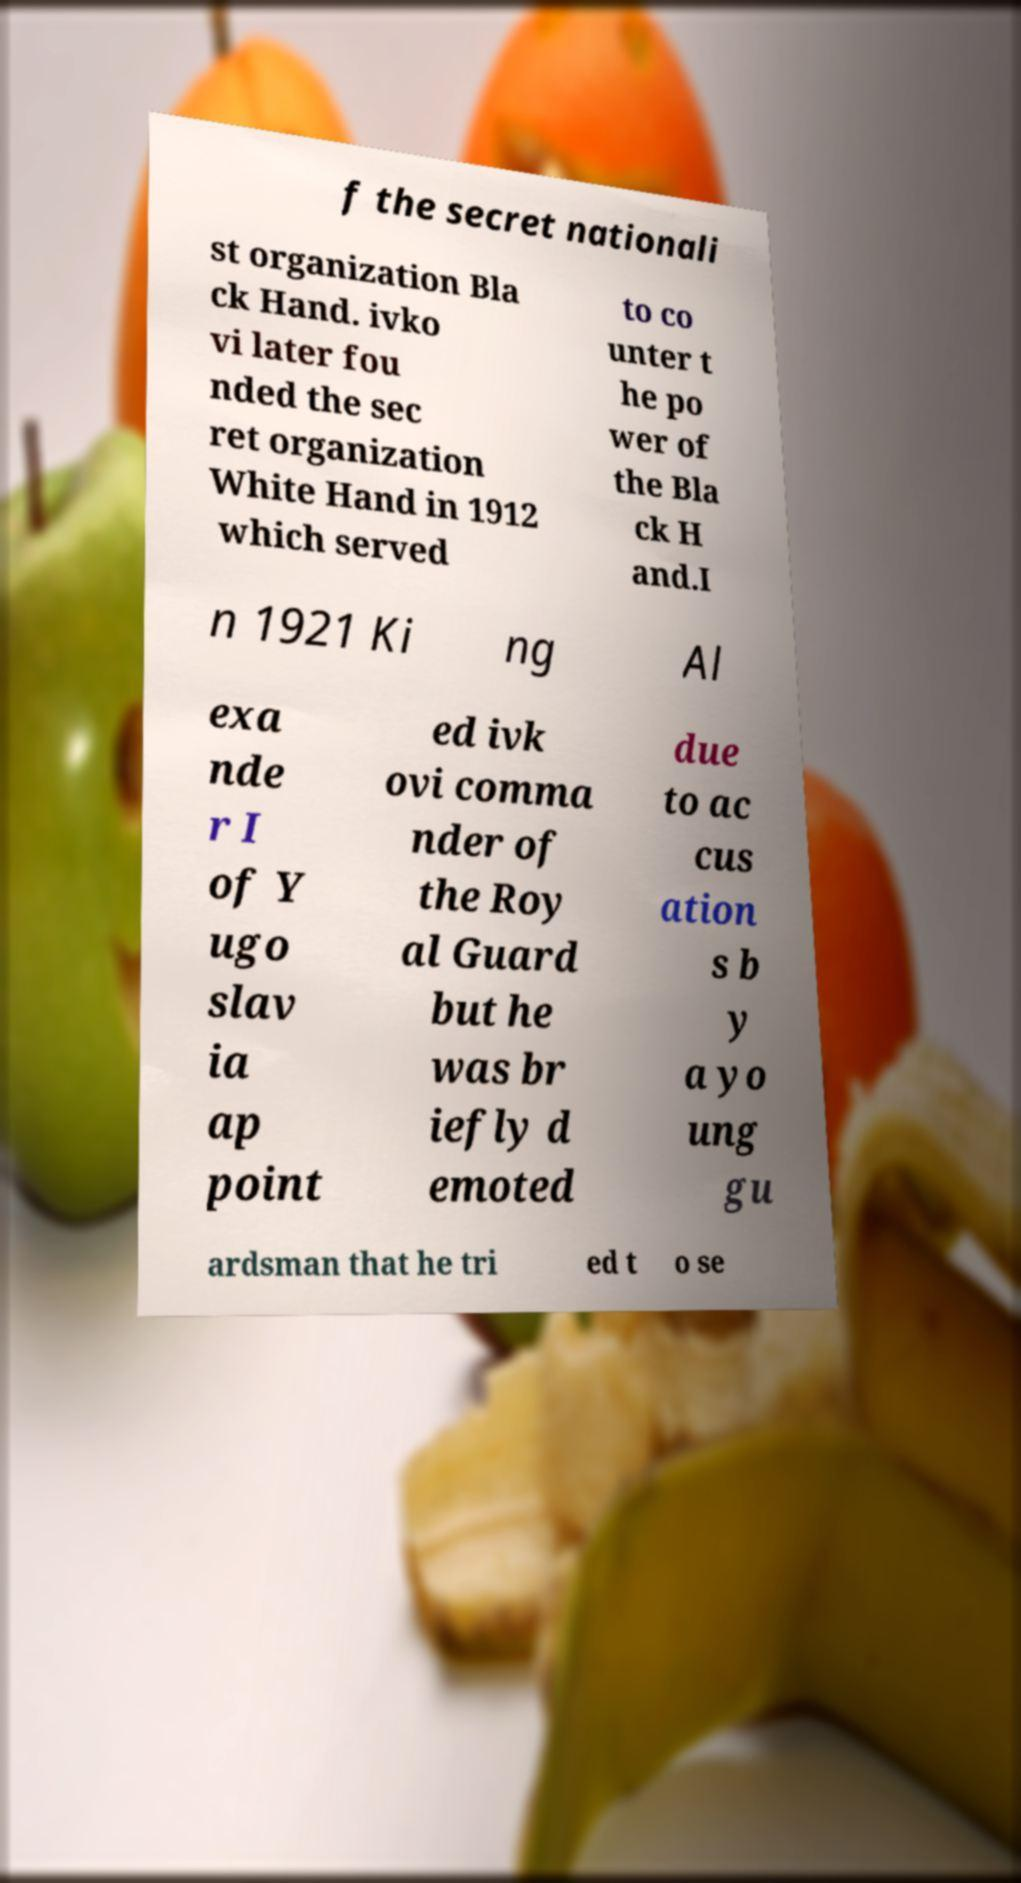Could you assist in decoding the text presented in this image and type it out clearly? f the secret nationali st organization Bla ck Hand. ivko vi later fou nded the sec ret organization White Hand in 1912 which served to co unter t he po wer of the Bla ck H and.I n 1921 Ki ng Al exa nde r I of Y ugo slav ia ap point ed ivk ovi comma nder of the Roy al Guard but he was br iefly d emoted due to ac cus ation s b y a yo ung gu ardsman that he tri ed t o se 